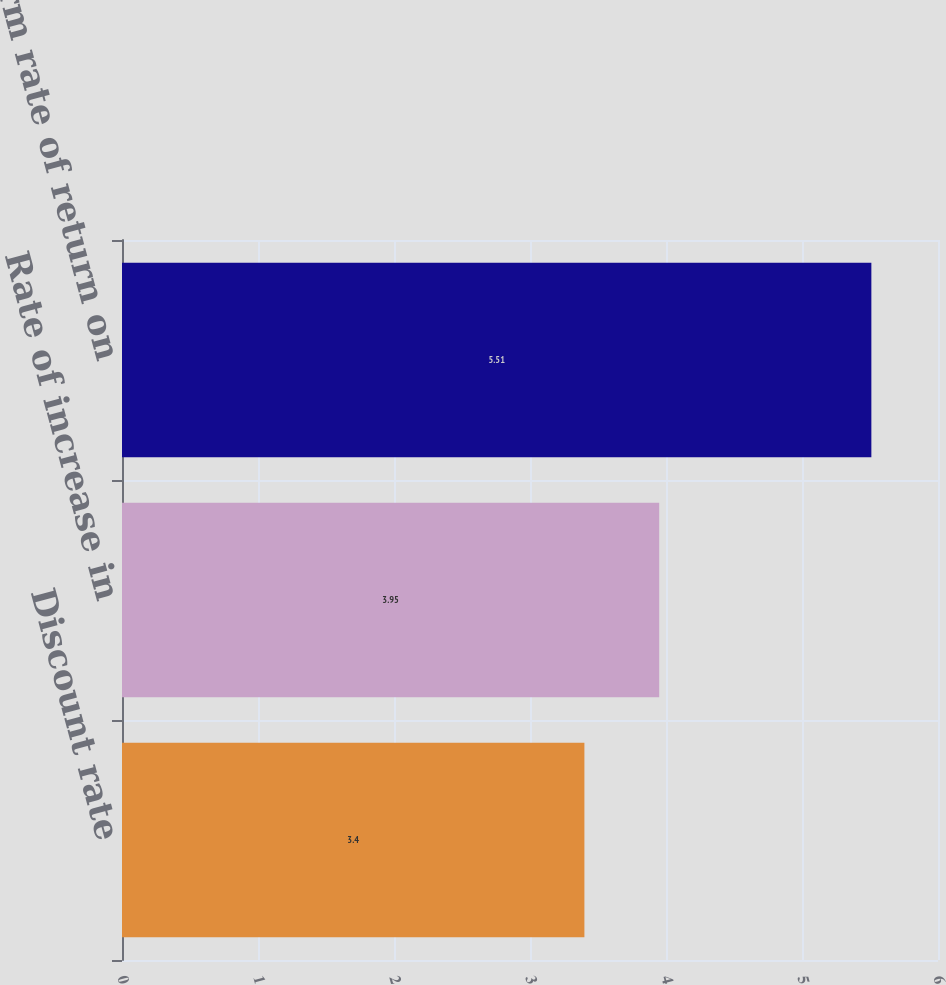Convert chart. <chart><loc_0><loc_0><loc_500><loc_500><bar_chart><fcel>Discount rate<fcel>Rate of increase in<fcel>Long-term rate of return on<nl><fcel>3.4<fcel>3.95<fcel>5.51<nl></chart> 